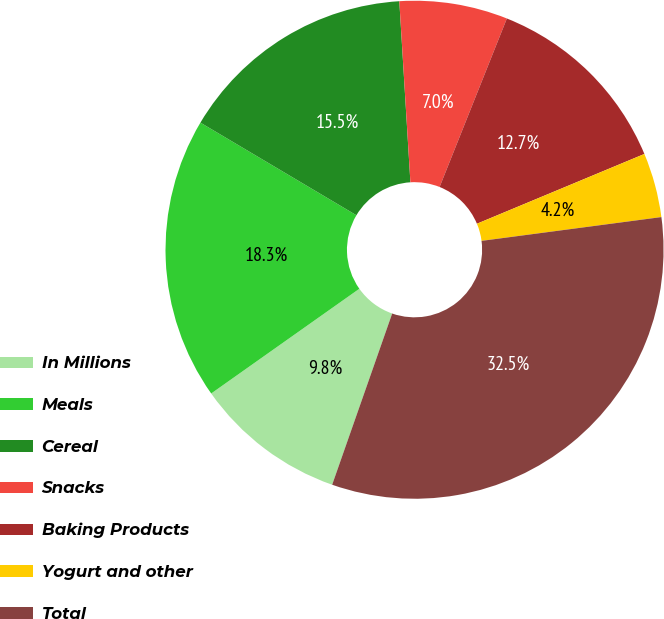Convert chart to OTSL. <chart><loc_0><loc_0><loc_500><loc_500><pie_chart><fcel>In Millions<fcel>Meals<fcel>Cereal<fcel>Snacks<fcel>Baking Products<fcel>Yogurt and other<fcel>Total<nl><fcel>9.84%<fcel>18.32%<fcel>15.5%<fcel>7.02%<fcel>12.67%<fcel>4.19%<fcel>32.46%<nl></chart> 